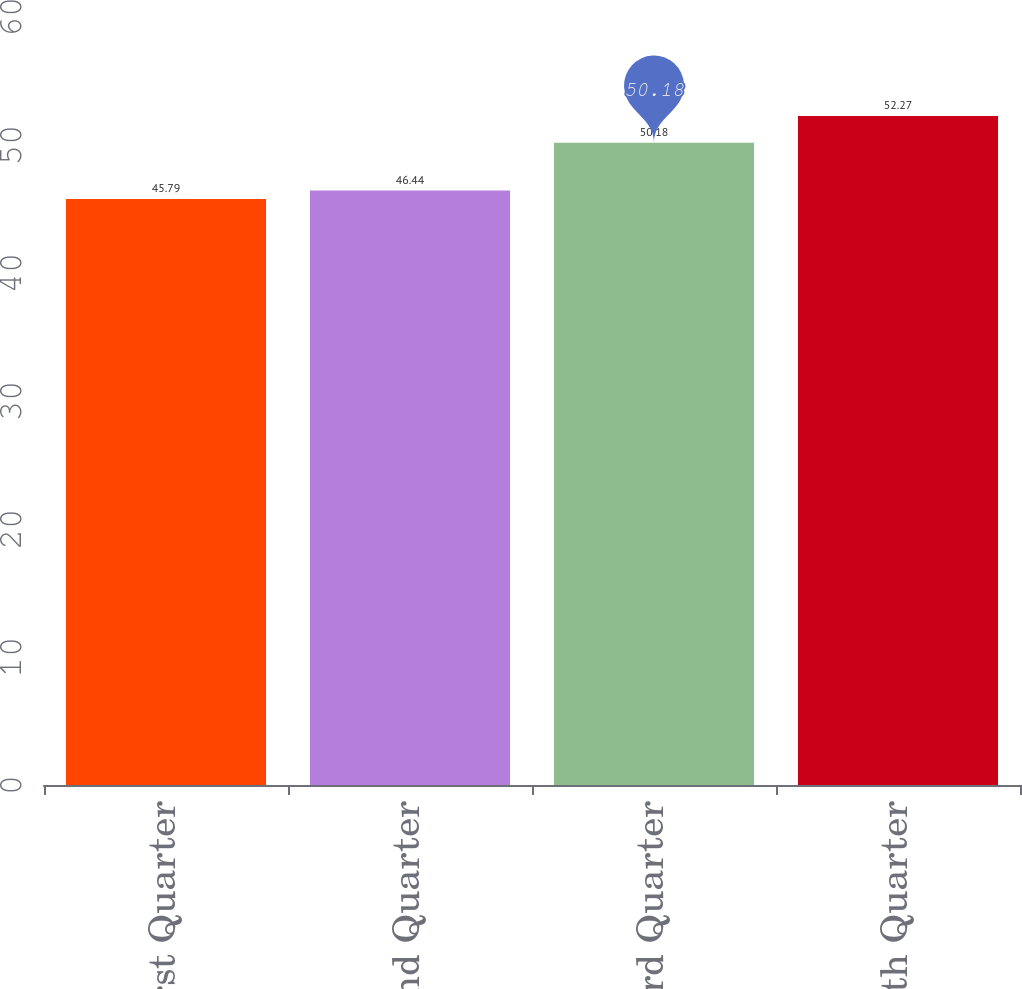Convert chart. <chart><loc_0><loc_0><loc_500><loc_500><bar_chart><fcel>First Quarter<fcel>Second Quarter<fcel>Third Quarter<fcel>Fourth Quarter<nl><fcel>45.79<fcel>46.44<fcel>50.18<fcel>52.27<nl></chart> 